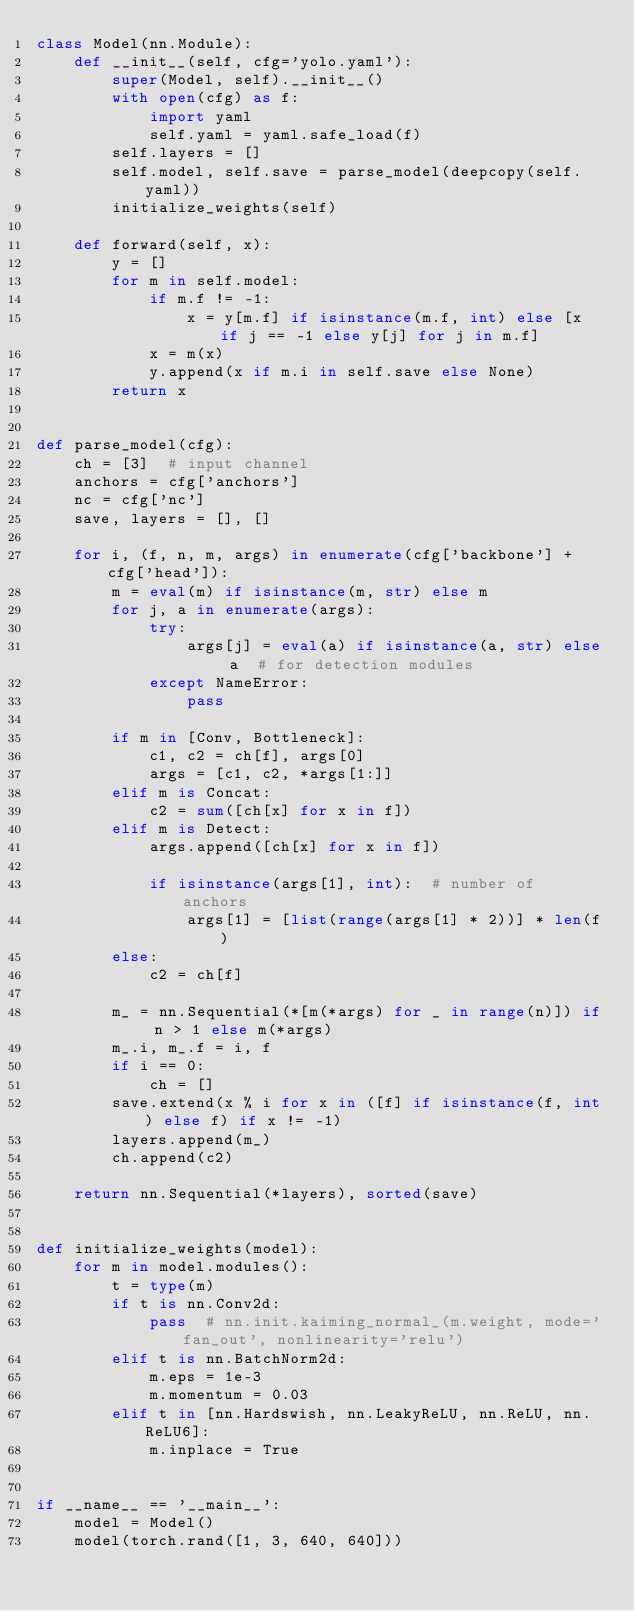Convert code to text. <code><loc_0><loc_0><loc_500><loc_500><_Python_>class Model(nn.Module):
    def __init__(self, cfg='yolo.yaml'):
        super(Model, self).__init__()
        with open(cfg) as f:
            import yaml
            self.yaml = yaml.safe_load(f)
        self.layers = []
        self.model, self.save = parse_model(deepcopy(self.yaml))
        initialize_weights(self)

    def forward(self, x):
        y = []
        for m in self.model:
            if m.f != -1:
                x = y[m.f] if isinstance(m.f, int) else [x if j == -1 else y[j] for j in m.f]
            x = m(x)
            y.append(x if m.i in self.save else None)
        return x


def parse_model(cfg):
    ch = [3]  # input channel
    anchors = cfg['anchors']
    nc = cfg['nc']
    save, layers = [], []

    for i, (f, n, m, args) in enumerate(cfg['backbone'] + cfg['head']):
        m = eval(m) if isinstance(m, str) else m
        for j, a in enumerate(args):
            try:
                args[j] = eval(a) if isinstance(a, str) else a  # for detection modules
            except NameError:
                pass

        if m in [Conv, Bottleneck]:
            c1, c2 = ch[f], args[0]
            args = [c1, c2, *args[1:]]
        elif m is Concat:
            c2 = sum([ch[x] for x in f])
        elif m is Detect:
            args.append([ch[x] for x in f])

            if isinstance(args[1], int):  # number of anchors
                args[1] = [list(range(args[1] * 2))] * len(f)
        else:
            c2 = ch[f]

        m_ = nn.Sequential(*[m(*args) for _ in range(n)]) if n > 1 else m(*args)
        m_.i, m_.f = i, f
        if i == 0:
            ch = []
        save.extend(x % i for x in ([f] if isinstance(f, int) else f) if x != -1)
        layers.append(m_)
        ch.append(c2)

    return nn.Sequential(*layers), sorted(save)


def initialize_weights(model):
    for m in model.modules():
        t = type(m)
        if t is nn.Conv2d:
            pass  # nn.init.kaiming_normal_(m.weight, mode='fan_out', nonlinearity='relu')
        elif t is nn.BatchNorm2d:
            m.eps = 1e-3
            m.momentum = 0.03
        elif t in [nn.Hardswish, nn.LeakyReLU, nn.ReLU, nn.ReLU6]:
            m.inplace = True


if __name__ == '__main__':
    model = Model()
    model(torch.rand([1, 3, 640, 640]))
</code> 